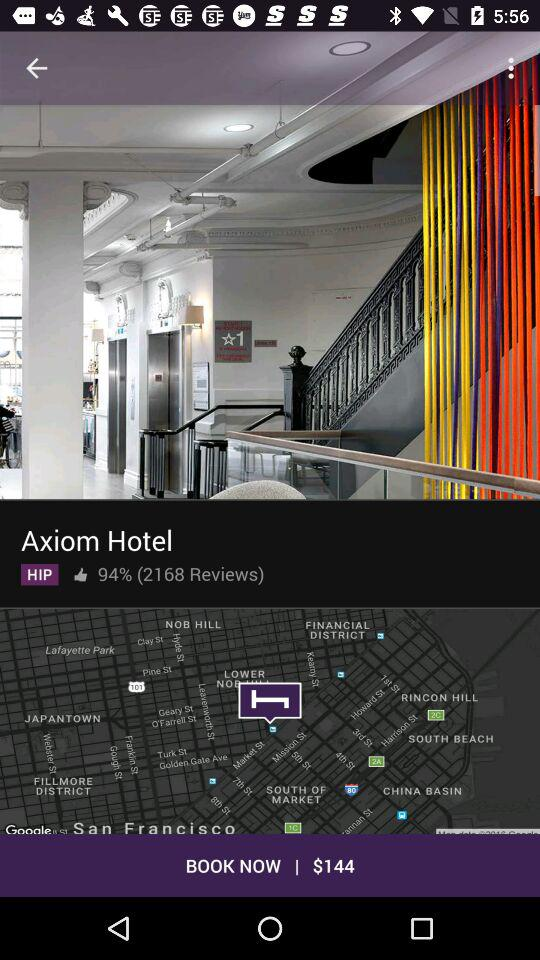What is the percentage of likes? The percentage of likes is 94. 